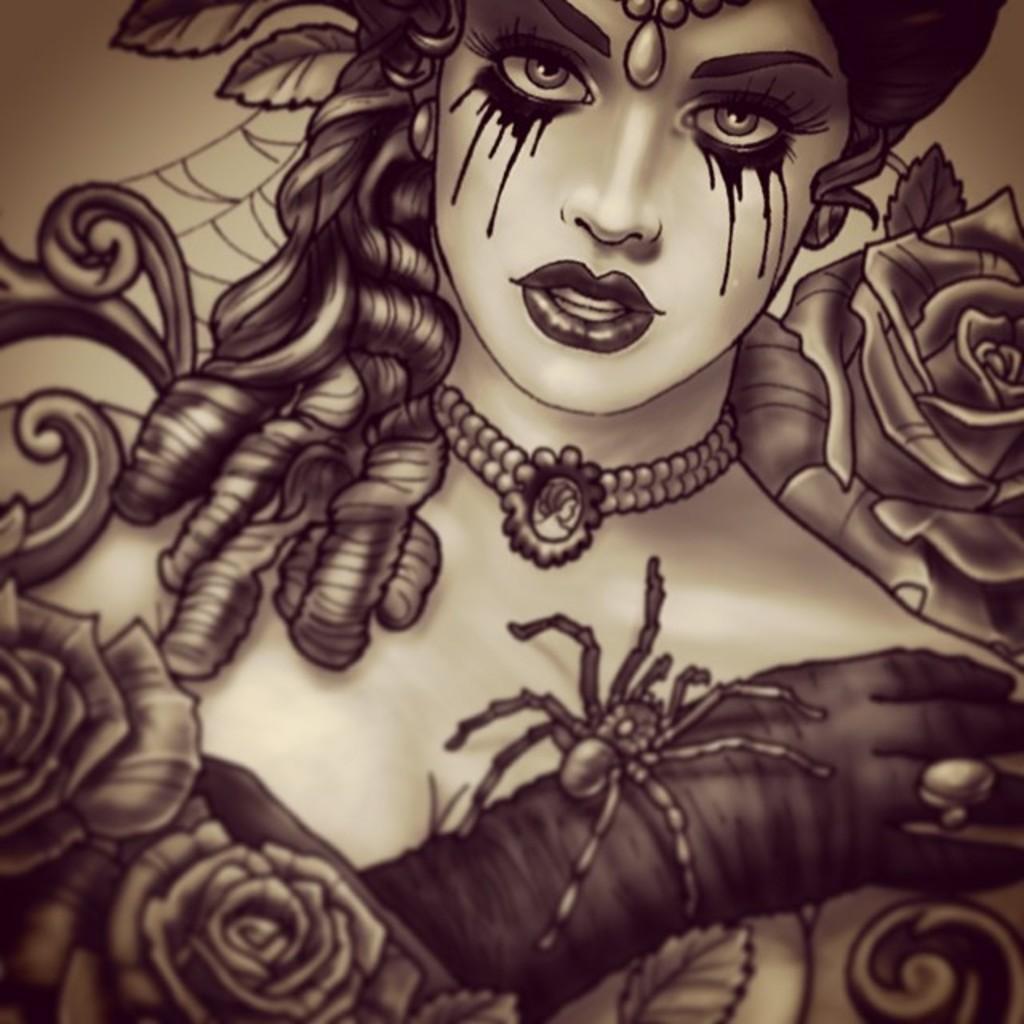Could you give a brief overview of what you see in this image? This is a sketch. In this picture we can see a lady is crying. On her hand, we can see a spider. 